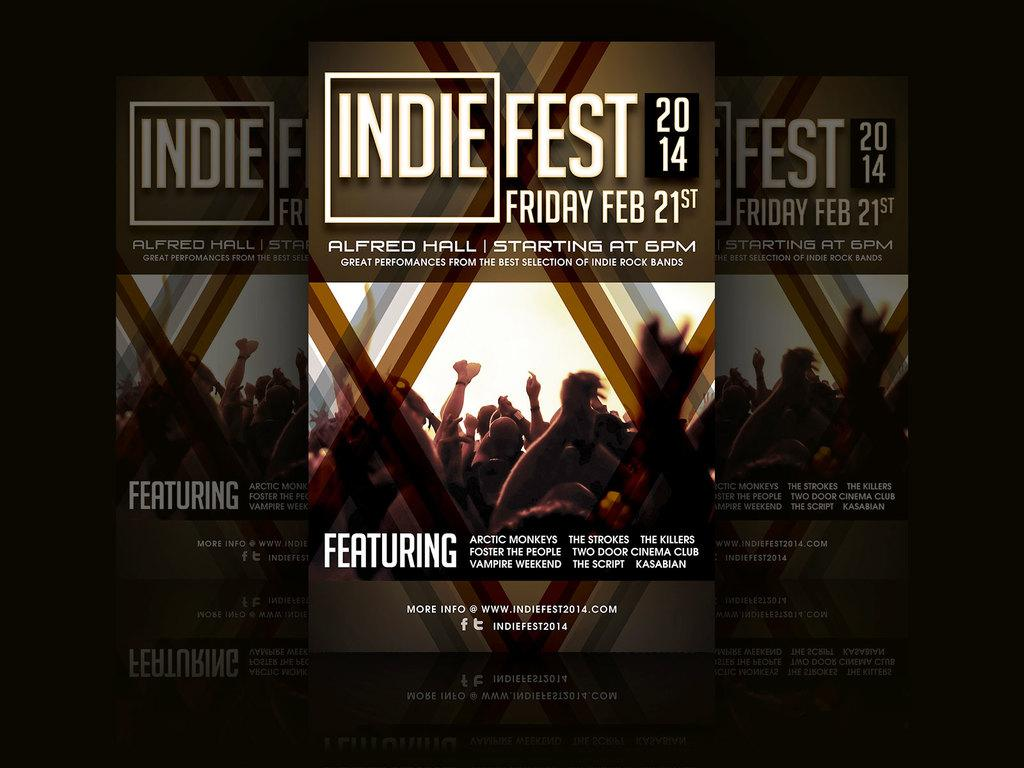<image>
Give a short and clear explanation of the subsequent image. posters for Indie Fest 2014 on Friday Feb 21 